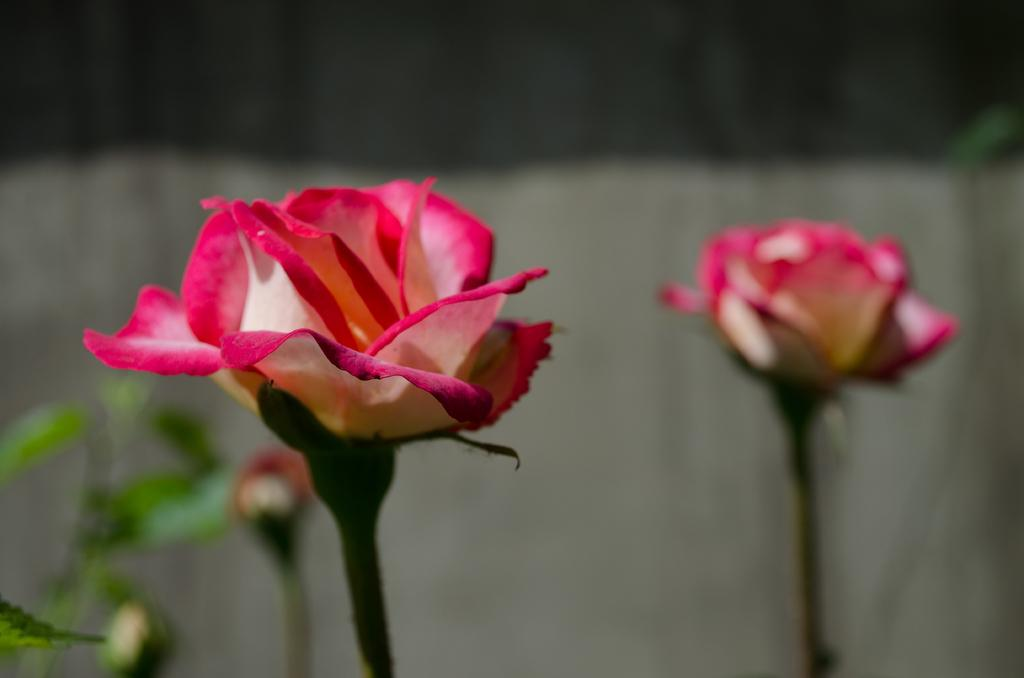What is present in the image? There are flowers in the image. Can you describe the background of the image? The background of the image is blurry. What type of writing can be seen on the flowers in the image? There is no writing present on the flowers in the image. Is there a snake visible among the flowers in the image? There is no snake present in the image; it only features flowers. 